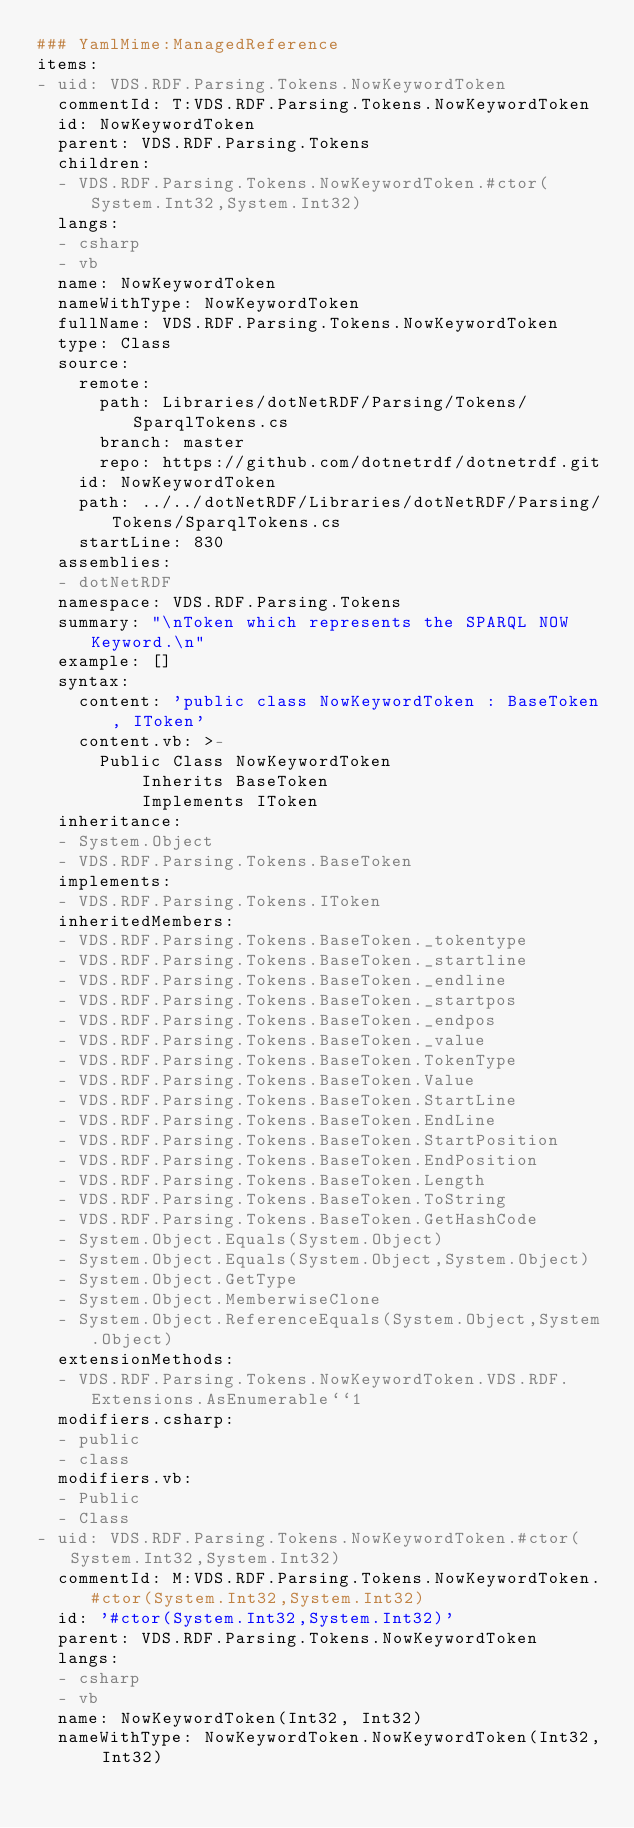<code> <loc_0><loc_0><loc_500><loc_500><_YAML_>### YamlMime:ManagedReference
items:
- uid: VDS.RDF.Parsing.Tokens.NowKeywordToken
  commentId: T:VDS.RDF.Parsing.Tokens.NowKeywordToken
  id: NowKeywordToken
  parent: VDS.RDF.Parsing.Tokens
  children:
  - VDS.RDF.Parsing.Tokens.NowKeywordToken.#ctor(System.Int32,System.Int32)
  langs:
  - csharp
  - vb
  name: NowKeywordToken
  nameWithType: NowKeywordToken
  fullName: VDS.RDF.Parsing.Tokens.NowKeywordToken
  type: Class
  source:
    remote:
      path: Libraries/dotNetRDF/Parsing/Tokens/SparqlTokens.cs
      branch: master
      repo: https://github.com/dotnetrdf/dotnetrdf.git
    id: NowKeywordToken
    path: ../../dotNetRDF/Libraries/dotNetRDF/Parsing/Tokens/SparqlTokens.cs
    startLine: 830
  assemblies:
  - dotNetRDF
  namespace: VDS.RDF.Parsing.Tokens
  summary: "\nToken which represents the SPARQL NOW Keyword.\n"
  example: []
  syntax:
    content: 'public class NowKeywordToken : BaseToken, IToken'
    content.vb: >-
      Public Class NowKeywordToken
          Inherits BaseToken
          Implements IToken
  inheritance:
  - System.Object
  - VDS.RDF.Parsing.Tokens.BaseToken
  implements:
  - VDS.RDF.Parsing.Tokens.IToken
  inheritedMembers:
  - VDS.RDF.Parsing.Tokens.BaseToken._tokentype
  - VDS.RDF.Parsing.Tokens.BaseToken._startline
  - VDS.RDF.Parsing.Tokens.BaseToken._endline
  - VDS.RDF.Parsing.Tokens.BaseToken._startpos
  - VDS.RDF.Parsing.Tokens.BaseToken._endpos
  - VDS.RDF.Parsing.Tokens.BaseToken._value
  - VDS.RDF.Parsing.Tokens.BaseToken.TokenType
  - VDS.RDF.Parsing.Tokens.BaseToken.Value
  - VDS.RDF.Parsing.Tokens.BaseToken.StartLine
  - VDS.RDF.Parsing.Tokens.BaseToken.EndLine
  - VDS.RDF.Parsing.Tokens.BaseToken.StartPosition
  - VDS.RDF.Parsing.Tokens.BaseToken.EndPosition
  - VDS.RDF.Parsing.Tokens.BaseToken.Length
  - VDS.RDF.Parsing.Tokens.BaseToken.ToString
  - VDS.RDF.Parsing.Tokens.BaseToken.GetHashCode
  - System.Object.Equals(System.Object)
  - System.Object.Equals(System.Object,System.Object)
  - System.Object.GetType
  - System.Object.MemberwiseClone
  - System.Object.ReferenceEquals(System.Object,System.Object)
  extensionMethods:
  - VDS.RDF.Parsing.Tokens.NowKeywordToken.VDS.RDF.Extensions.AsEnumerable``1
  modifiers.csharp:
  - public
  - class
  modifiers.vb:
  - Public
  - Class
- uid: VDS.RDF.Parsing.Tokens.NowKeywordToken.#ctor(System.Int32,System.Int32)
  commentId: M:VDS.RDF.Parsing.Tokens.NowKeywordToken.#ctor(System.Int32,System.Int32)
  id: '#ctor(System.Int32,System.Int32)'
  parent: VDS.RDF.Parsing.Tokens.NowKeywordToken
  langs:
  - csharp
  - vb
  name: NowKeywordToken(Int32, Int32)
  nameWithType: NowKeywordToken.NowKeywordToken(Int32, Int32)</code> 